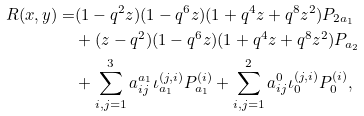<formula> <loc_0><loc_0><loc_500><loc_500>R ( x , y ) = & ( 1 - q ^ { 2 } z ) ( 1 - q ^ { 6 } z ) ( 1 + q ^ { 4 } z + q ^ { 8 } z ^ { 2 } ) P _ { 2 \L a _ { 1 } } \\ & + ( z - q ^ { 2 } ) ( 1 - q ^ { 6 } z ) ( 1 + q ^ { 4 } z + q ^ { 8 } z ^ { 2 } ) P _ { \L a _ { 2 } } \\ & + \sum _ { i , j = 1 } ^ { 3 } a ^ { \L a _ { 1 } } _ { i j } \iota ^ { ( j , i ) } _ { \L a _ { 1 } } P _ { \L a _ { 1 } } ^ { ( i ) } + \sum _ { i , j = 1 } ^ { 2 } a ^ { 0 } _ { i j } \iota ^ { ( j , i ) } _ { 0 } P _ { 0 } ^ { ( i ) } ,</formula> 